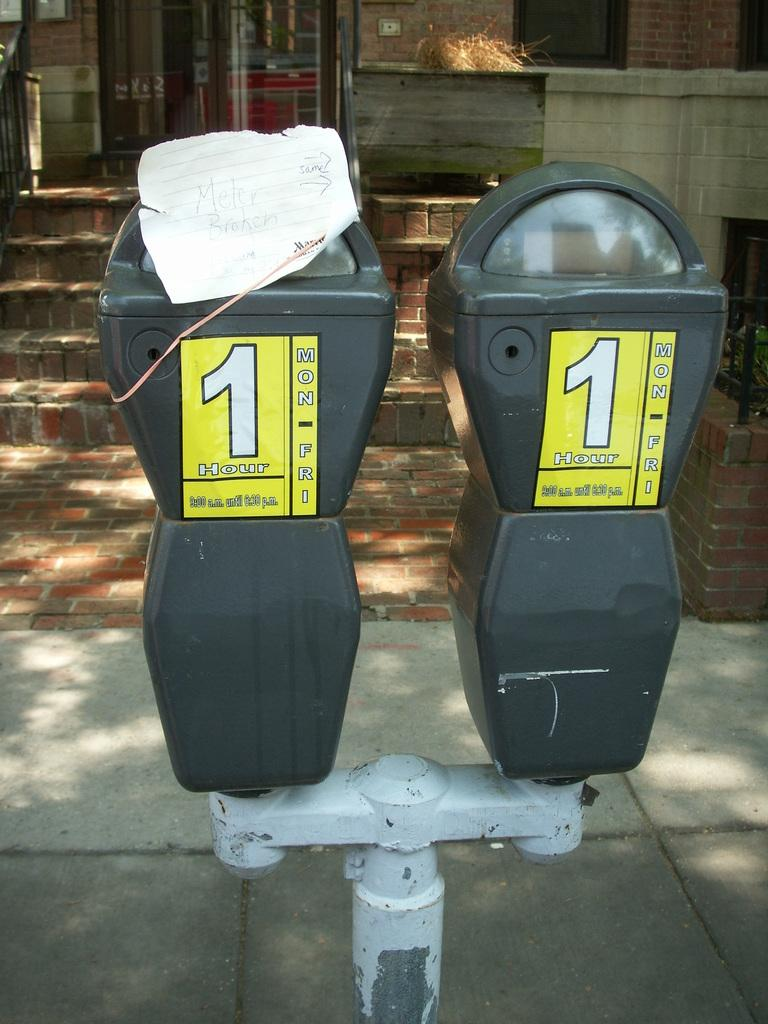<image>
Render a clear and concise summary of the photo. Two parking meters with a yellow sticker on them with a 1 on the center. 